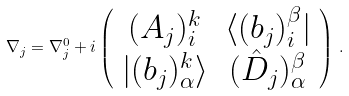<formula> <loc_0><loc_0><loc_500><loc_500>\nabla _ { j } = \nabla _ { j } ^ { 0 } + i \left ( \begin{array} { c c } { { ( A _ { j } ) _ { i } ^ { k } } } & { { \langle ( b _ { j } ) _ { i } ^ { \beta } | } } \\ { { | ( b _ { j } ) _ { \alpha } ^ { k } \rangle } } & { { ( \hat { D } _ { j } ) _ { \alpha } ^ { \beta } } } \end{array} \right ) \, .</formula> 